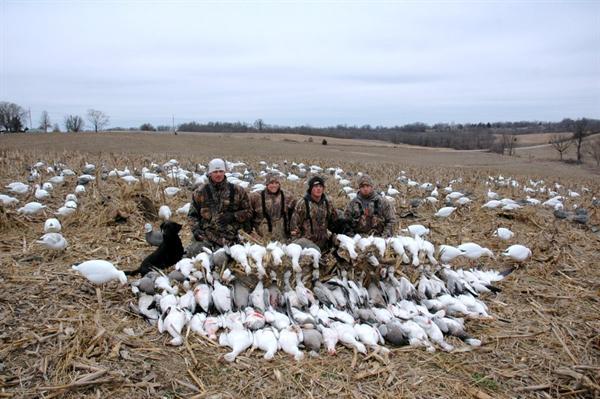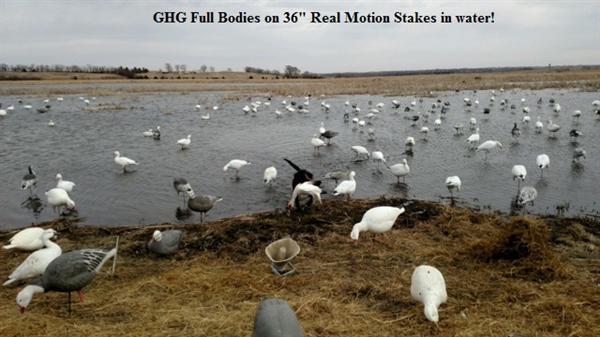The first image is the image on the left, the second image is the image on the right. Analyze the images presented: Is the assertion "Two birds in the left image have dark bodies and white heads." valid? Answer yes or no. No. The first image is the image on the left, the second image is the image on the right. Considering the images on both sides, is "The left image includes a row of white and darker grayer duck decoys, and the right image features a white duck decoy closest to the camera." valid? Answer yes or no. No. 